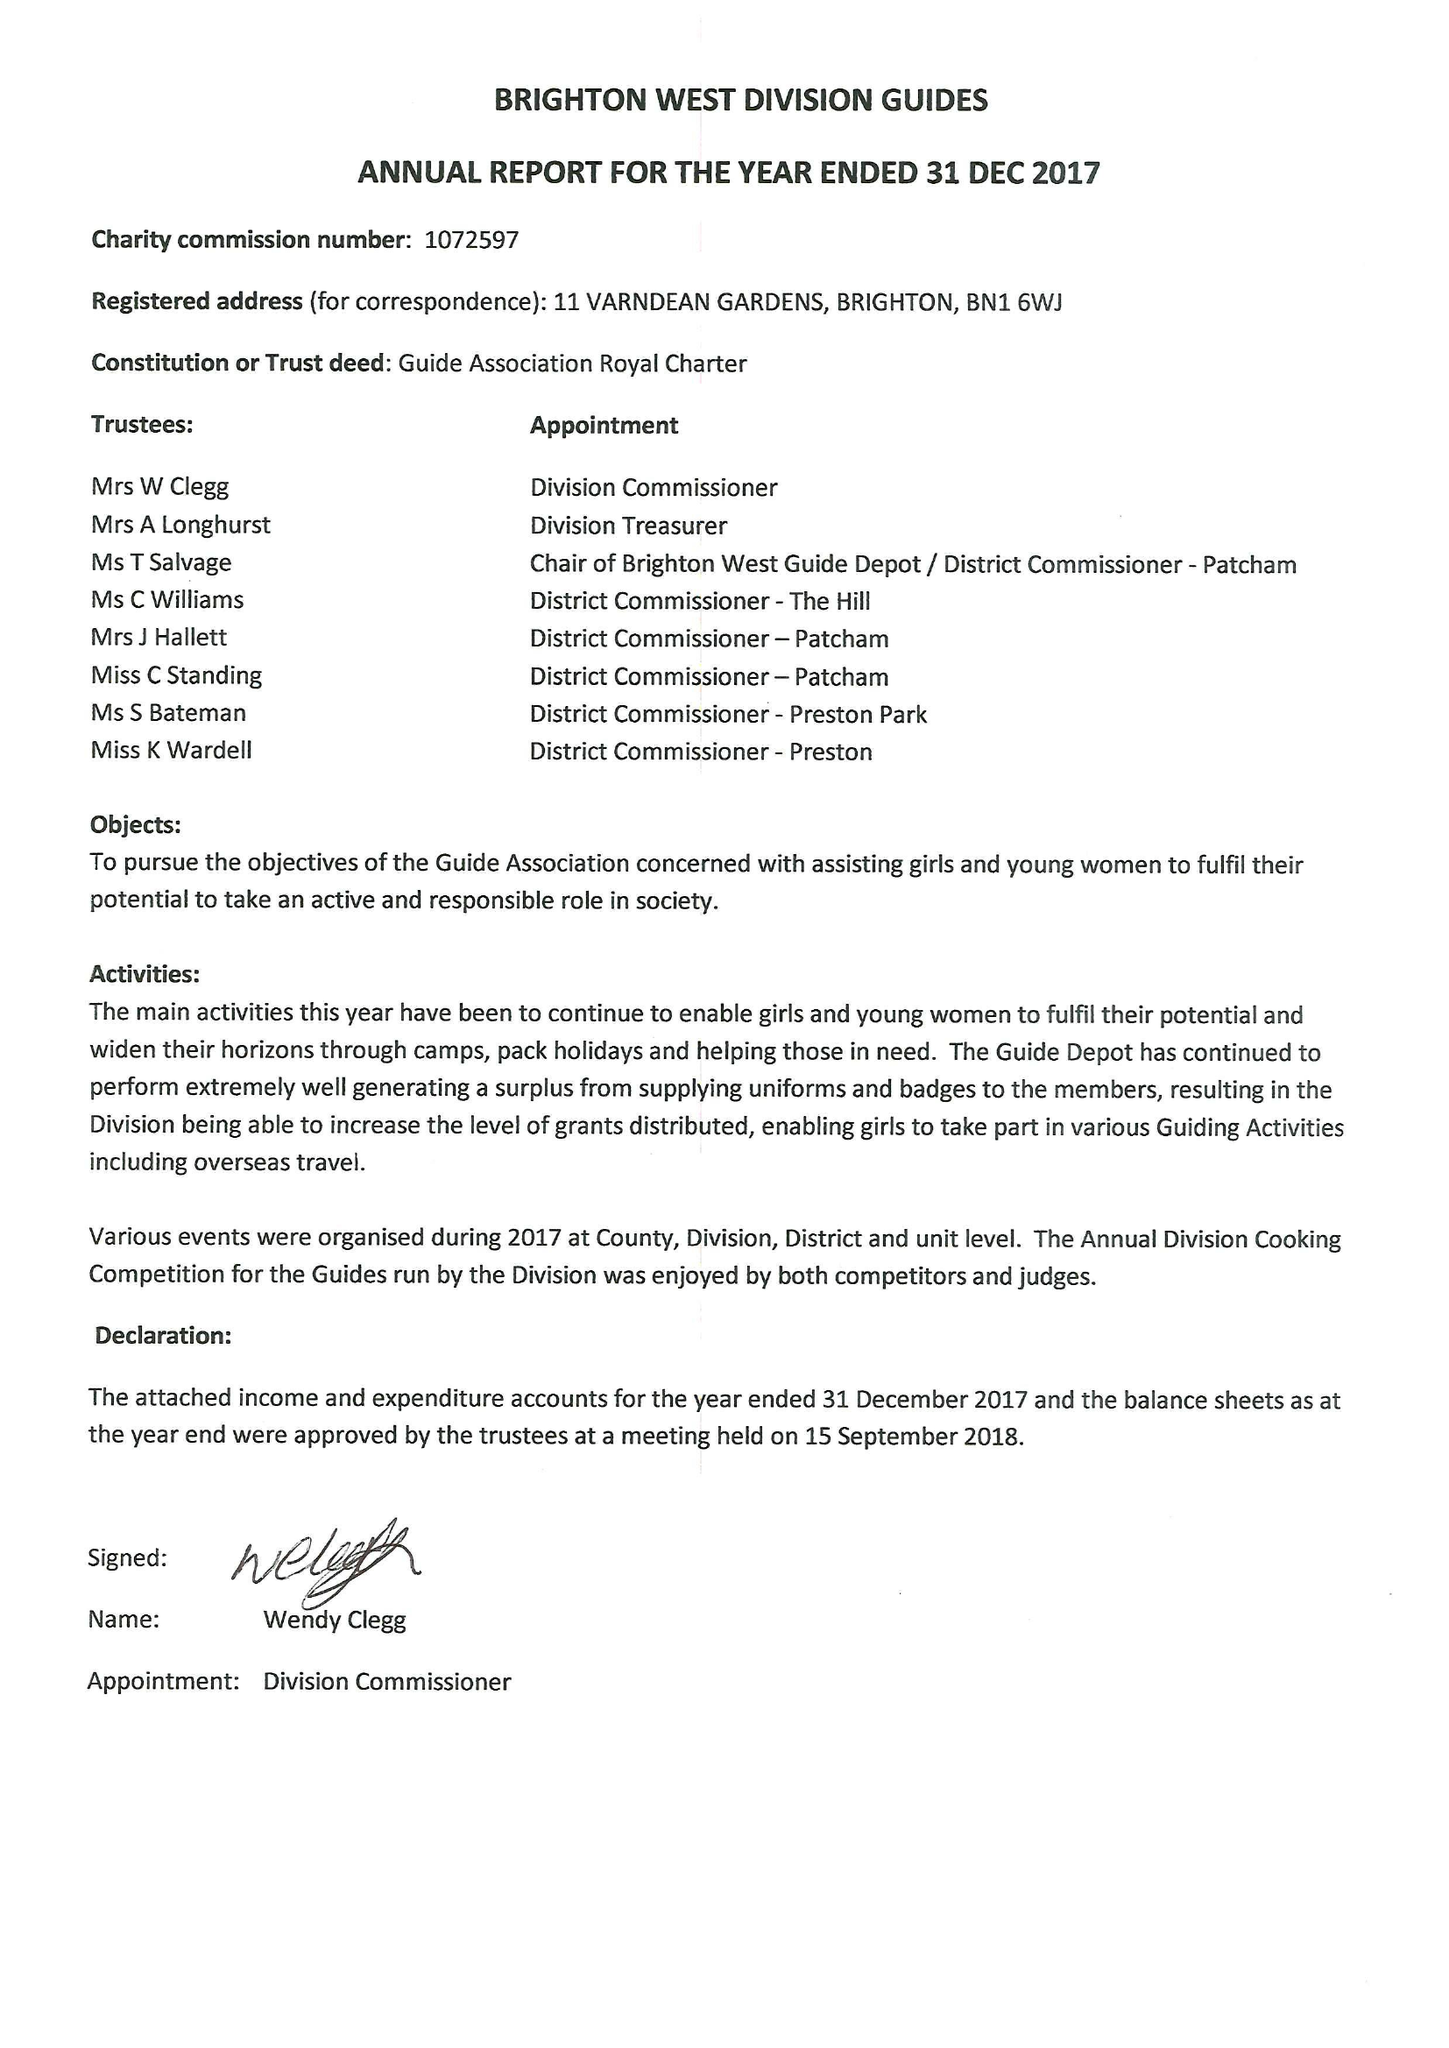What is the value for the spending_annually_in_british_pounds?
Answer the question using a single word or phrase. 34314.00 